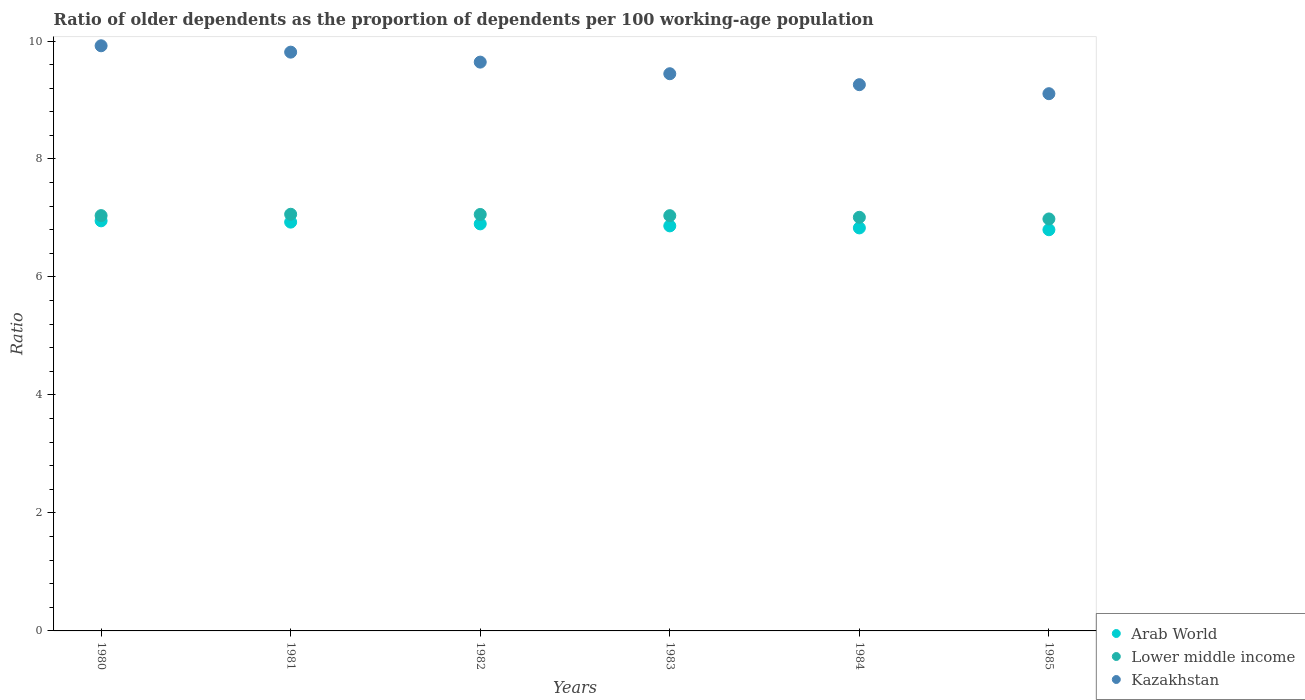How many different coloured dotlines are there?
Give a very brief answer. 3. Is the number of dotlines equal to the number of legend labels?
Provide a short and direct response. Yes. What is the age dependency ratio(old) in Arab World in 1983?
Offer a very short reply. 6.87. Across all years, what is the maximum age dependency ratio(old) in Kazakhstan?
Ensure brevity in your answer.  9.92. Across all years, what is the minimum age dependency ratio(old) in Lower middle income?
Provide a short and direct response. 6.98. In which year was the age dependency ratio(old) in Kazakhstan minimum?
Your answer should be very brief. 1985. What is the total age dependency ratio(old) in Lower middle income in the graph?
Your response must be concise. 42.2. What is the difference between the age dependency ratio(old) in Arab World in 1982 and that in 1984?
Provide a short and direct response. 0.07. What is the difference between the age dependency ratio(old) in Lower middle income in 1981 and the age dependency ratio(old) in Kazakhstan in 1982?
Keep it short and to the point. -2.58. What is the average age dependency ratio(old) in Kazakhstan per year?
Your answer should be compact. 9.53. In the year 1981, what is the difference between the age dependency ratio(old) in Lower middle income and age dependency ratio(old) in Arab World?
Make the answer very short. 0.13. What is the ratio of the age dependency ratio(old) in Lower middle income in 1981 to that in 1985?
Your answer should be compact. 1.01. What is the difference between the highest and the second highest age dependency ratio(old) in Lower middle income?
Provide a short and direct response. 0. What is the difference between the highest and the lowest age dependency ratio(old) in Lower middle income?
Your answer should be very brief. 0.08. In how many years, is the age dependency ratio(old) in Kazakhstan greater than the average age dependency ratio(old) in Kazakhstan taken over all years?
Make the answer very short. 3. Is it the case that in every year, the sum of the age dependency ratio(old) in Kazakhstan and age dependency ratio(old) in Lower middle income  is greater than the age dependency ratio(old) in Arab World?
Keep it short and to the point. Yes. How many dotlines are there?
Offer a terse response. 3. What is the difference between two consecutive major ticks on the Y-axis?
Your answer should be compact. 2. Are the values on the major ticks of Y-axis written in scientific E-notation?
Your response must be concise. No. Does the graph contain any zero values?
Provide a succinct answer. No. Does the graph contain grids?
Your answer should be compact. No. Where does the legend appear in the graph?
Ensure brevity in your answer.  Bottom right. What is the title of the graph?
Ensure brevity in your answer.  Ratio of older dependents as the proportion of dependents per 100 working-age population. Does "Timor-Leste" appear as one of the legend labels in the graph?
Keep it short and to the point. No. What is the label or title of the Y-axis?
Your answer should be compact. Ratio. What is the Ratio of Arab World in 1980?
Provide a succinct answer. 6.95. What is the Ratio in Lower middle income in 1980?
Keep it short and to the point. 7.04. What is the Ratio of Kazakhstan in 1980?
Provide a short and direct response. 9.92. What is the Ratio in Arab World in 1981?
Provide a succinct answer. 6.93. What is the Ratio of Lower middle income in 1981?
Your response must be concise. 7.06. What is the Ratio in Kazakhstan in 1981?
Offer a terse response. 9.81. What is the Ratio of Arab World in 1982?
Your answer should be compact. 6.9. What is the Ratio in Lower middle income in 1982?
Keep it short and to the point. 7.06. What is the Ratio in Kazakhstan in 1982?
Make the answer very short. 9.64. What is the Ratio of Arab World in 1983?
Offer a terse response. 6.87. What is the Ratio of Lower middle income in 1983?
Offer a very short reply. 7.04. What is the Ratio of Kazakhstan in 1983?
Your answer should be compact. 9.45. What is the Ratio in Arab World in 1984?
Offer a very short reply. 6.83. What is the Ratio in Lower middle income in 1984?
Provide a short and direct response. 7.01. What is the Ratio in Kazakhstan in 1984?
Keep it short and to the point. 9.26. What is the Ratio of Arab World in 1985?
Give a very brief answer. 6.8. What is the Ratio of Lower middle income in 1985?
Make the answer very short. 6.98. What is the Ratio in Kazakhstan in 1985?
Offer a terse response. 9.11. Across all years, what is the maximum Ratio of Arab World?
Ensure brevity in your answer.  6.95. Across all years, what is the maximum Ratio of Lower middle income?
Offer a terse response. 7.06. Across all years, what is the maximum Ratio of Kazakhstan?
Keep it short and to the point. 9.92. Across all years, what is the minimum Ratio of Arab World?
Offer a very short reply. 6.8. Across all years, what is the minimum Ratio in Lower middle income?
Offer a terse response. 6.98. Across all years, what is the minimum Ratio in Kazakhstan?
Provide a short and direct response. 9.11. What is the total Ratio of Arab World in the graph?
Make the answer very short. 41.28. What is the total Ratio of Lower middle income in the graph?
Ensure brevity in your answer.  42.2. What is the total Ratio in Kazakhstan in the graph?
Your answer should be compact. 57.18. What is the difference between the Ratio of Arab World in 1980 and that in 1981?
Give a very brief answer. 0.02. What is the difference between the Ratio in Lower middle income in 1980 and that in 1981?
Ensure brevity in your answer.  -0.02. What is the difference between the Ratio of Kazakhstan in 1980 and that in 1981?
Your response must be concise. 0.11. What is the difference between the Ratio of Arab World in 1980 and that in 1982?
Ensure brevity in your answer.  0.05. What is the difference between the Ratio in Lower middle income in 1980 and that in 1982?
Make the answer very short. -0.02. What is the difference between the Ratio of Kazakhstan in 1980 and that in 1982?
Provide a short and direct response. 0.28. What is the difference between the Ratio in Arab World in 1980 and that in 1983?
Your answer should be compact. 0.09. What is the difference between the Ratio in Lower middle income in 1980 and that in 1983?
Offer a terse response. 0. What is the difference between the Ratio in Kazakhstan in 1980 and that in 1983?
Ensure brevity in your answer.  0.47. What is the difference between the Ratio of Arab World in 1980 and that in 1984?
Your answer should be very brief. 0.12. What is the difference between the Ratio in Lower middle income in 1980 and that in 1984?
Your answer should be compact. 0.03. What is the difference between the Ratio in Kazakhstan in 1980 and that in 1984?
Offer a very short reply. 0.66. What is the difference between the Ratio in Arab World in 1980 and that in 1985?
Provide a succinct answer. 0.15. What is the difference between the Ratio in Lower middle income in 1980 and that in 1985?
Give a very brief answer. 0.06. What is the difference between the Ratio in Kazakhstan in 1980 and that in 1985?
Your response must be concise. 0.81. What is the difference between the Ratio in Arab World in 1981 and that in 1982?
Give a very brief answer. 0.03. What is the difference between the Ratio of Lower middle income in 1981 and that in 1982?
Provide a succinct answer. 0. What is the difference between the Ratio of Kazakhstan in 1981 and that in 1982?
Ensure brevity in your answer.  0.17. What is the difference between the Ratio in Arab World in 1981 and that in 1983?
Offer a terse response. 0.06. What is the difference between the Ratio of Lower middle income in 1981 and that in 1983?
Provide a succinct answer. 0.02. What is the difference between the Ratio of Kazakhstan in 1981 and that in 1983?
Offer a very short reply. 0.37. What is the difference between the Ratio of Arab World in 1981 and that in 1984?
Offer a terse response. 0.1. What is the difference between the Ratio in Lower middle income in 1981 and that in 1984?
Provide a short and direct response. 0.05. What is the difference between the Ratio in Kazakhstan in 1981 and that in 1984?
Your answer should be very brief. 0.55. What is the difference between the Ratio of Arab World in 1981 and that in 1985?
Provide a short and direct response. 0.13. What is the difference between the Ratio in Lower middle income in 1981 and that in 1985?
Keep it short and to the point. 0.08. What is the difference between the Ratio of Kazakhstan in 1981 and that in 1985?
Ensure brevity in your answer.  0.7. What is the difference between the Ratio of Arab World in 1982 and that in 1983?
Ensure brevity in your answer.  0.03. What is the difference between the Ratio in Lower middle income in 1982 and that in 1983?
Your answer should be compact. 0.02. What is the difference between the Ratio in Kazakhstan in 1982 and that in 1983?
Ensure brevity in your answer.  0.2. What is the difference between the Ratio in Arab World in 1982 and that in 1984?
Your response must be concise. 0.07. What is the difference between the Ratio in Lower middle income in 1982 and that in 1984?
Ensure brevity in your answer.  0.05. What is the difference between the Ratio in Kazakhstan in 1982 and that in 1984?
Make the answer very short. 0.38. What is the difference between the Ratio of Arab World in 1982 and that in 1985?
Give a very brief answer. 0.1. What is the difference between the Ratio of Lower middle income in 1982 and that in 1985?
Your response must be concise. 0.08. What is the difference between the Ratio of Kazakhstan in 1982 and that in 1985?
Give a very brief answer. 0.54. What is the difference between the Ratio in Arab World in 1983 and that in 1984?
Give a very brief answer. 0.03. What is the difference between the Ratio in Lower middle income in 1983 and that in 1984?
Give a very brief answer. 0.03. What is the difference between the Ratio in Kazakhstan in 1983 and that in 1984?
Make the answer very short. 0.19. What is the difference between the Ratio in Arab World in 1983 and that in 1985?
Your response must be concise. 0.07. What is the difference between the Ratio of Lower middle income in 1983 and that in 1985?
Your answer should be compact. 0.06. What is the difference between the Ratio in Kazakhstan in 1983 and that in 1985?
Provide a short and direct response. 0.34. What is the difference between the Ratio of Arab World in 1984 and that in 1985?
Ensure brevity in your answer.  0.03. What is the difference between the Ratio of Lower middle income in 1984 and that in 1985?
Offer a very short reply. 0.03. What is the difference between the Ratio of Kazakhstan in 1984 and that in 1985?
Your response must be concise. 0.15. What is the difference between the Ratio in Arab World in 1980 and the Ratio in Lower middle income in 1981?
Ensure brevity in your answer.  -0.11. What is the difference between the Ratio of Arab World in 1980 and the Ratio of Kazakhstan in 1981?
Ensure brevity in your answer.  -2.86. What is the difference between the Ratio in Lower middle income in 1980 and the Ratio in Kazakhstan in 1981?
Make the answer very short. -2.77. What is the difference between the Ratio of Arab World in 1980 and the Ratio of Lower middle income in 1982?
Provide a succinct answer. -0.11. What is the difference between the Ratio of Arab World in 1980 and the Ratio of Kazakhstan in 1982?
Your answer should be compact. -2.69. What is the difference between the Ratio of Lower middle income in 1980 and the Ratio of Kazakhstan in 1982?
Provide a succinct answer. -2.6. What is the difference between the Ratio of Arab World in 1980 and the Ratio of Lower middle income in 1983?
Your answer should be compact. -0.09. What is the difference between the Ratio in Arab World in 1980 and the Ratio in Kazakhstan in 1983?
Your answer should be very brief. -2.49. What is the difference between the Ratio of Lower middle income in 1980 and the Ratio of Kazakhstan in 1983?
Offer a terse response. -2.4. What is the difference between the Ratio of Arab World in 1980 and the Ratio of Lower middle income in 1984?
Give a very brief answer. -0.06. What is the difference between the Ratio in Arab World in 1980 and the Ratio in Kazakhstan in 1984?
Give a very brief answer. -2.31. What is the difference between the Ratio in Lower middle income in 1980 and the Ratio in Kazakhstan in 1984?
Your answer should be very brief. -2.22. What is the difference between the Ratio of Arab World in 1980 and the Ratio of Lower middle income in 1985?
Your answer should be very brief. -0.03. What is the difference between the Ratio in Arab World in 1980 and the Ratio in Kazakhstan in 1985?
Ensure brevity in your answer.  -2.16. What is the difference between the Ratio in Lower middle income in 1980 and the Ratio in Kazakhstan in 1985?
Give a very brief answer. -2.07. What is the difference between the Ratio in Arab World in 1981 and the Ratio in Lower middle income in 1982?
Your answer should be very brief. -0.13. What is the difference between the Ratio of Arab World in 1981 and the Ratio of Kazakhstan in 1982?
Offer a terse response. -2.71. What is the difference between the Ratio of Lower middle income in 1981 and the Ratio of Kazakhstan in 1982?
Your answer should be very brief. -2.58. What is the difference between the Ratio of Arab World in 1981 and the Ratio of Lower middle income in 1983?
Ensure brevity in your answer.  -0.11. What is the difference between the Ratio in Arab World in 1981 and the Ratio in Kazakhstan in 1983?
Make the answer very short. -2.52. What is the difference between the Ratio in Lower middle income in 1981 and the Ratio in Kazakhstan in 1983?
Provide a short and direct response. -2.38. What is the difference between the Ratio in Arab World in 1981 and the Ratio in Lower middle income in 1984?
Ensure brevity in your answer.  -0.08. What is the difference between the Ratio in Arab World in 1981 and the Ratio in Kazakhstan in 1984?
Your answer should be very brief. -2.33. What is the difference between the Ratio in Lower middle income in 1981 and the Ratio in Kazakhstan in 1984?
Keep it short and to the point. -2.2. What is the difference between the Ratio in Arab World in 1981 and the Ratio in Lower middle income in 1985?
Give a very brief answer. -0.05. What is the difference between the Ratio in Arab World in 1981 and the Ratio in Kazakhstan in 1985?
Offer a very short reply. -2.18. What is the difference between the Ratio in Lower middle income in 1981 and the Ratio in Kazakhstan in 1985?
Your answer should be compact. -2.04. What is the difference between the Ratio in Arab World in 1982 and the Ratio in Lower middle income in 1983?
Provide a short and direct response. -0.14. What is the difference between the Ratio in Arab World in 1982 and the Ratio in Kazakhstan in 1983?
Your answer should be very brief. -2.55. What is the difference between the Ratio of Lower middle income in 1982 and the Ratio of Kazakhstan in 1983?
Your response must be concise. -2.39. What is the difference between the Ratio in Arab World in 1982 and the Ratio in Lower middle income in 1984?
Your answer should be compact. -0.11. What is the difference between the Ratio in Arab World in 1982 and the Ratio in Kazakhstan in 1984?
Give a very brief answer. -2.36. What is the difference between the Ratio in Lower middle income in 1982 and the Ratio in Kazakhstan in 1984?
Your answer should be compact. -2.2. What is the difference between the Ratio of Arab World in 1982 and the Ratio of Lower middle income in 1985?
Ensure brevity in your answer.  -0.08. What is the difference between the Ratio in Arab World in 1982 and the Ratio in Kazakhstan in 1985?
Make the answer very short. -2.21. What is the difference between the Ratio in Lower middle income in 1982 and the Ratio in Kazakhstan in 1985?
Make the answer very short. -2.05. What is the difference between the Ratio in Arab World in 1983 and the Ratio in Lower middle income in 1984?
Provide a succinct answer. -0.15. What is the difference between the Ratio of Arab World in 1983 and the Ratio of Kazakhstan in 1984?
Your answer should be compact. -2.39. What is the difference between the Ratio of Lower middle income in 1983 and the Ratio of Kazakhstan in 1984?
Your answer should be compact. -2.22. What is the difference between the Ratio of Arab World in 1983 and the Ratio of Lower middle income in 1985?
Ensure brevity in your answer.  -0.12. What is the difference between the Ratio in Arab World in 1983 and the Ratio in Kazakhstan in 1985?
Offer a very short reply. -2.24. What is the difference between the Ratio in Lower middle income in 1983 and the Ratio in Kazakhstan in 1985?
Make the answer very short. -2.07. What is the difference between the Ratio in Arab World in 1984 and the Ratio in Lower middle income in 1985?
Your answer should be very brief. -0.15. What is the difference between the Ratio in Arab World in 1984 and the Ratio in Kazakhstan in 1985?
Make the answer very short. -2.28. What is the difference between the Ratio of Lower middle income in 1984 and the Ratio of Kazakhstan in 1985?
Make the answer very short. -2.1. What is the average Ratio in Arab World per year?
Keep it short and to the point. 6.88. What is the average Ratio in Lower middle income per year?
Your answer should be very brief. 7.03. What is the average Ratio in Kazakhstan per year?
Keep it short and to the point. 9.53. In the year 1980, what is the difference between the Ratio of Arab World and Ratio of Lower middle income?
Offer a terse response. -0.09. In the year 1980, what is the difference between the Ratio in Arab World and Ratio in Kazakhstan?
Your response must be concise. -2.97. In the year 1980, what is the difference between the Ratio in Lower middle income and Ratio in Kazakhstan?
Keep it short and to the point. -2.88. In the year 1981, what is the difference between the Ratio in Arab World and Ratio in Lower middle income?
Your response must be concise. -0.13. In the year 1981, what is the difference between the Ratio of Arab World and Ratio of Kazakhstan?
Offer a very short reply. -2.88. In the year 1981, what is the difference between the Ratio of Lower middle income and Ratio of Kazakhstan?
Your answer should be very brief. -2.75. In the year 1982, what is the difference between the Ratio of Arab World and Ratio of Lower middle income?
Give a very brief answer. -0.16. In the year 1982, what is the difference between the Ratio of Arab World and Ratio of Kazakhstan?
Make the answer very short. -2.74. In the year 1982, what is the difference between the Ratio in Lower middle income and Ratio in Kazakhstan?
Provide a short and direct response. -2.58. In the year 1983, what is the difference between the Ratio in Arab World and Ratio in Lower middle income?
Your response must be concise. -0.17. In the year 1983, what is the difference between the Ratio in Arab World and Ratio in Kazakhstan?
Ensure brevity in your answer.  -2.58. In the year 1983, what is the difference between the Ratio in Lower middle income and Ratio in Kazakhstan?
Your response must be concise. -2.41. In the year 1984, what is the difference between the Ratio of Arab World and Ratio of Lower middle income?
Keep it short and to the point. -0.18. In the year 1984, what is the difference between the Ratio in Arab World and Ratio in Kazakhstan?
Offer a terse response. -2.43. In the year 1984, what is the difference between the Ratio of Lower middle income and Ratio of Kazakhstan?
Your response must be concise. -2.25. In the year 1985, what is the difference between the Ratio in Arab World and Ratio in Lower middle income?
Make the answer very short. -0.18. In the year 1985, what is the difference between the Ratio in Arab World and Ratio in Kazakhstan?
Give a very brief answer. -2.31. In the year 1985, what is the difference between the Ratio in Lower middle income and Ratio in Kazakhstan?
Your answer should be very brief. -2.12. What is the ratio of the Ratio in Arab World in 1980 to that in 1981?
Make the answer very short. 1. What is the ratio of the Ratio of Lower middle income in 1980 to that in 1981?
Your answer should be compact. 1. What is the ratio of the Ratio of Kazakhstan in 1980 to that in 1981?
Ensure brevity in your answer.  1.01. What is the ratio of the Ratio in Arab World in 1980 to that in 1982?
Keep it short and to the point. 1.01. What is the ratio of the Ratio of Lower middle income in 1980 to that in 1982?
Your answer should be very brief. 1. What is the ratio of the Ratio in Kazakhstan in 1980 to that in 1982?
Offer a terse response. 1.03. What is the ratio of the Ratio of Arab World in 1980 to that in 1983?
Provide a succinct answer. 1.01. What is the ratio of the Ratio of Lower middle income in 1980 to that in 1983?
Your answer should be compact. 1. What is the ratio of the Ratio of Kazakhstan in 1980 to that in 1983?
Offer a terse response. 1.05. What is the ratio of the Ratio in Arab World in 1980 to that in 1984?
Give a very brief answer. 1.02. What is the ratio of the Ratio in Kazakhstan in 1980 to that in 1984?
Make the answer very short. 1.07. What is the ratio of the Ratio of Arab World in 1980 to that in 1985?
Offer a very short reply. 1.02. What is the ratio of the Ratio in Kazakhstan in 1980 to that in 1985?
Provide a short and direct response. 1.09. What is the ratio of the Ratio of Kazakhstan in 1981 to that in 1982?
Keep it short and to the point. 1.02. What is the ratio of the Ratio of Arab World in 1981 to that in 1983?
Provide a short and direct response. 1.01. What is the ratio of the Ratio of Kazakhstan in 1981 to that in 1983?
Your answer should be compact. 1.04. What is the ratio of the Ratio of Arab World in 1981 to that in 1984?
Your response must be concise. 1.01. What is the ratio of the Ratio of Lower middle income in 1981 to that in 1984?
Keep it short and to the point. 1.01. What is the ratio of the Ratio of Kazakhstan in 1981 to that in 1984?
Your answer should be very brief. 1.06. What is the ratio of the Ratio in Arab World in 1981 to that in 1985?
Your answer should be very brief. 1.02. What is the ratio of the Ratio of Lower middle income in 1981 to that in 1985?
Keep it short and to the point. 1.01. What is the ratio of the Ratio in Kazakhstan in 1981 to that in 1985?
Ensure brevity in your answer.  1.08. What is the ratio of the Ratio of Arab World in 1982 to that in 1983?
Your answer should be compact. 1. What is the ratio of the Ratio of Kazakhstan in 1982 to that in 1983?
Provide a succinct answer. 1.02. What is the ratio of the Ratio in Lower middle income in 1982 to that in 1984?
Offer a terse response. 1.01. What is the ratio of the Ratio in Kazakhstan in 1982 to that in 1984?
Your answer should be very brief. 1.04. What is the ratio of the Ratio of Arab World in 1982 to that in 1985?
Make the answer very short. 1.01. What is the ratio of the Ratio in Lower middle income in 1982 to that in 1985?
Offer a terse response. 1.01. What is the ratio of the Ratio in Kazakhstan in 1982 to that in 1985?
Offer a very short reply. 1.06. What is the ratio of the Ratio in Lower middle income in 1983 to that in 1984?
Provide a short and direct response. 1. What is the ratio of the Ratio in Kazakhstan in 1983 to that in 1984?
Provide a short and direct response. 1.02. What is the ratio of the Ratio in Arab World in 1983 to that in 1985?
Make the answer very short. 1.01. What is the ratio of the Ratio of Lower middle income in 1983 to that in 1985?
Your response must be concise. 1.01. What is the ratio of the Ratio of Kazakhstan in 1983 to that in 1985?
Make the answer very short. 1.04. What is the ratio of the Ratio of Kazakhstan in 1984 to that in 1985?
Your answer should be very brief. 1.02. What is the difference between the highest and the second highest Ratio of Arab World?
Ensure brevity in your answer.  0.02. What is the difference between the highest and the second highest Ratio of Lower middle income?
Give a very brief answer. 0. What is the difference between the highest and the second highest Ratio in Kazakhstan?
Your answer should be compact. 0.11. What is the difference between the highest and the lowest Ratio of Arab World?
Provide a short and direct response. 0.15. What is the difference between the highest and the lowest Ratio in Lower middle income?
Provide a succinct answer. 0.08. What is the difference between the highest and the lowest Ratio in Kazakhstan?
Provide a short and direct response. 0.81. 